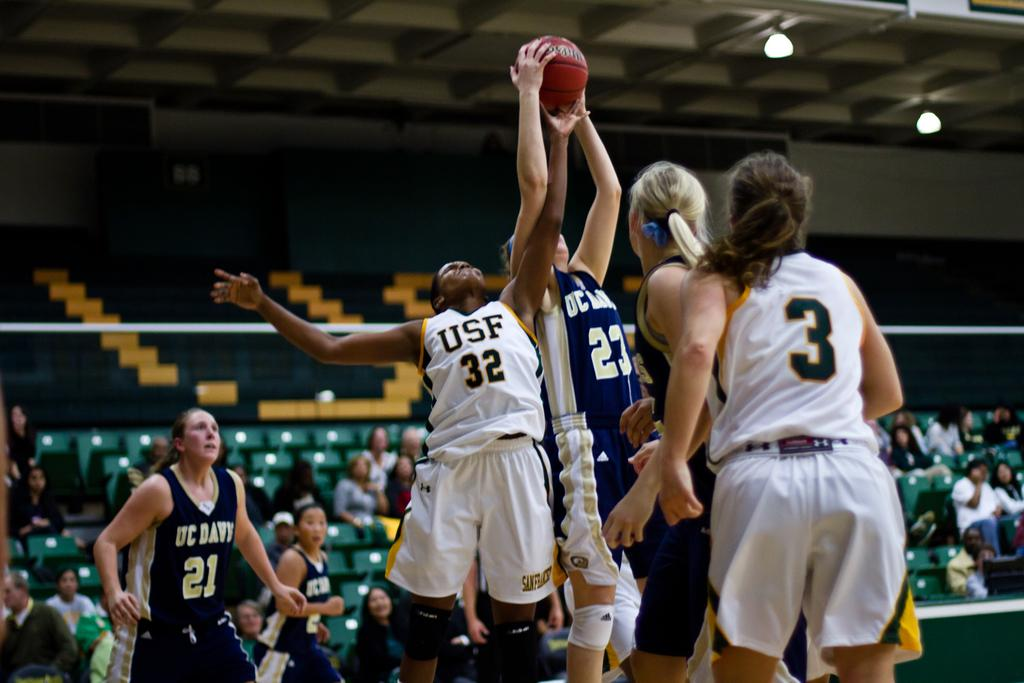<image>
Create a compact narrative representing the image presented. Girls from USF and UC Davy play a game of basketball. 